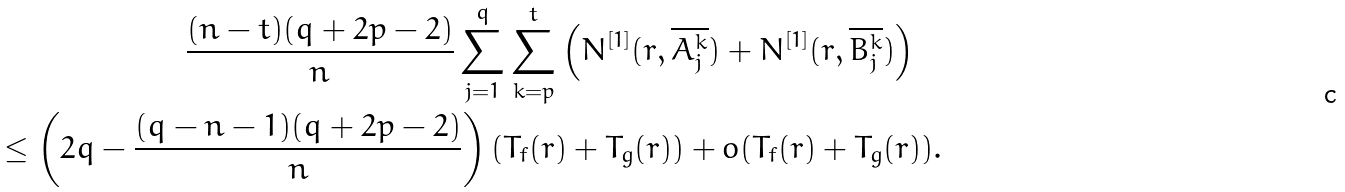Convert formula to latex. <formula><loc_0><loc_0><loc_500><loc_500>\frac { ( n - t ) ( q + 2 p - 2 ) } { n } \sum _ { j = 1 } ^ { q } \sum _ { k = p } ^ { t } \left ( N ^ { [ 1 ] } ( r , \overline { A _ { j } ^ { k } } ) + N ^ { [ 1 ] } ( r , \overline { B _ { j } ^ { k } } ) \right ) \quad \\ \leq \left ( 2 q - \frac { ( q - n - 1 ) ( q + 2 p - 2 ) } { n } \right ) ( T _ { f } ( r ) + T _ { g } ( r ) ) + o ( T _ { f } ( r ) + T _ { g } ( r ) ) .</formula> 